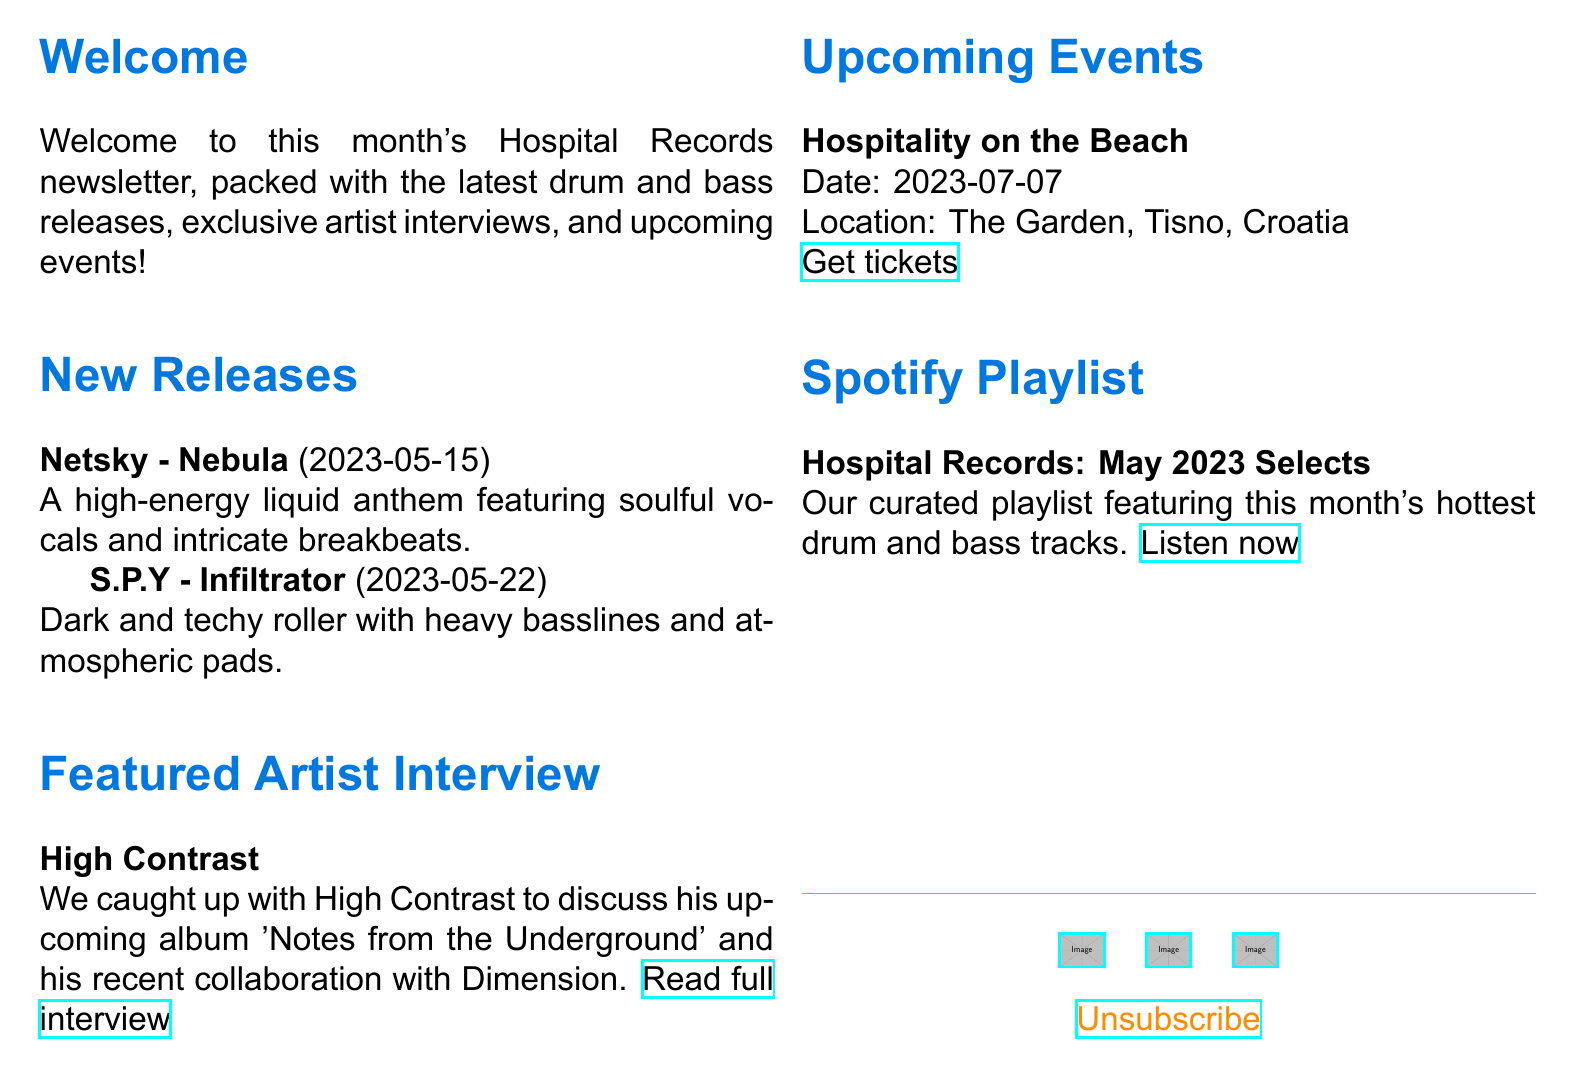What is the title of the newsletter? The title of the newsletter is prominently displayed at the top of the document.
Answer: Hospital Records Monthly Roundup Who is the featured artist in the interview? The interview section of the document highlights the artist's name.
Answer: High Contrast When was the track "Nebula" released? The release date for this track is mentioned in the new releases section.
Answer: 2023-05-15 What is the location of the upcoming event "Hospitality on the Beach"? The document specifies the location of the event in the upcoming events section.
Answer: The Garden, Tisno, Croatia What type of music does the Spotify playlist feature? The playlist description indicates the genre covered.
Answer: Drum and bass Which artist released the track "Infiltrator"? The artist's name is provided alongside the corresponding track in the new releases section.
Answer: S.P.Y What is the release date for the track "Infiltrator"? The document specifies the release date of the track clearly.
Answer: 2023-05-22 What is the title of High Contrast's upcoming album? The information is shared in the quoted interview snippet.
Answer: Notes from the Underground How can readers get tickets for the upcoming event? The document includes a link to obtain tickets under event details.
Answer: Get tickets 